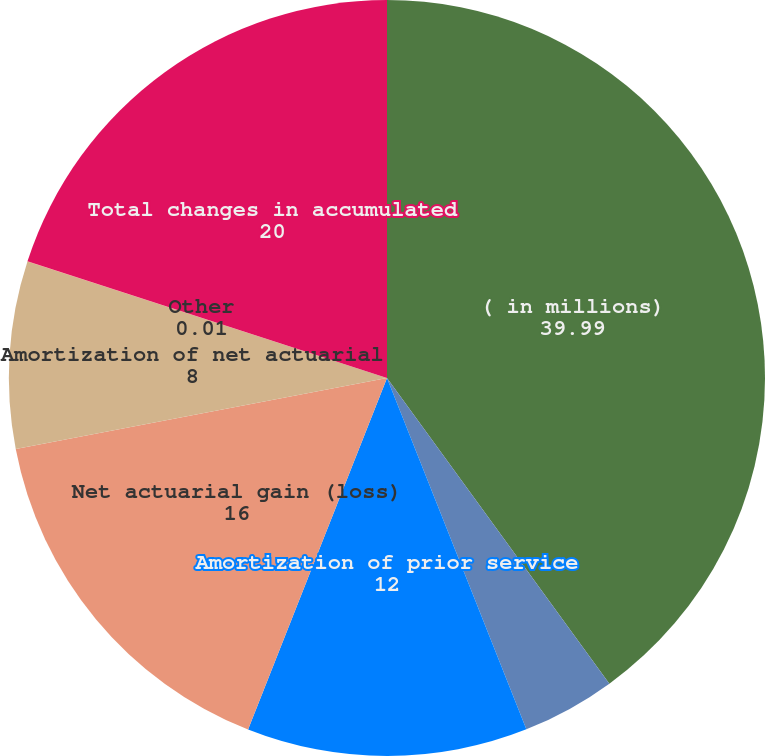<chart> <loc_0><loc_0><loc_500><loc_500><pie_chart><fcel>( in millions)<fcel>Prior service credit (cost)<fcel>Amortization of prior service<fcel>Net actuarial gain (loss)<fcel>Amortization of net actuarial<fcel>Other<fcel>Total changes in accumulated<nl><fcel>39.99%<fcel>4.0%<fcel>12.0%<fcel>16.0%<fcel>8.0%<fcel>0.01%<fcel>20.0%<nl></chart> 